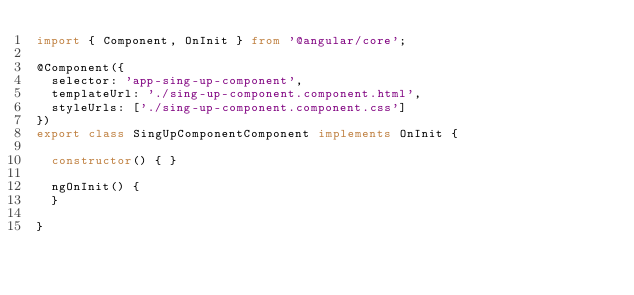<code> <loc_0><loc_0><loc_500><loc_500><_TypeScript_>import { Component, OnInit } from '@angular/core';

@Component({
  selector: 'app-sing-up-component',
  templateUrl: './sing-up-component.component.html',
  styleUrls: ['./sing-up-component.component.css']
})
export class SingUpComponentComponent implements OnInit {

  constructor() { }

  ngOnInit() {
  }

}
</code> 